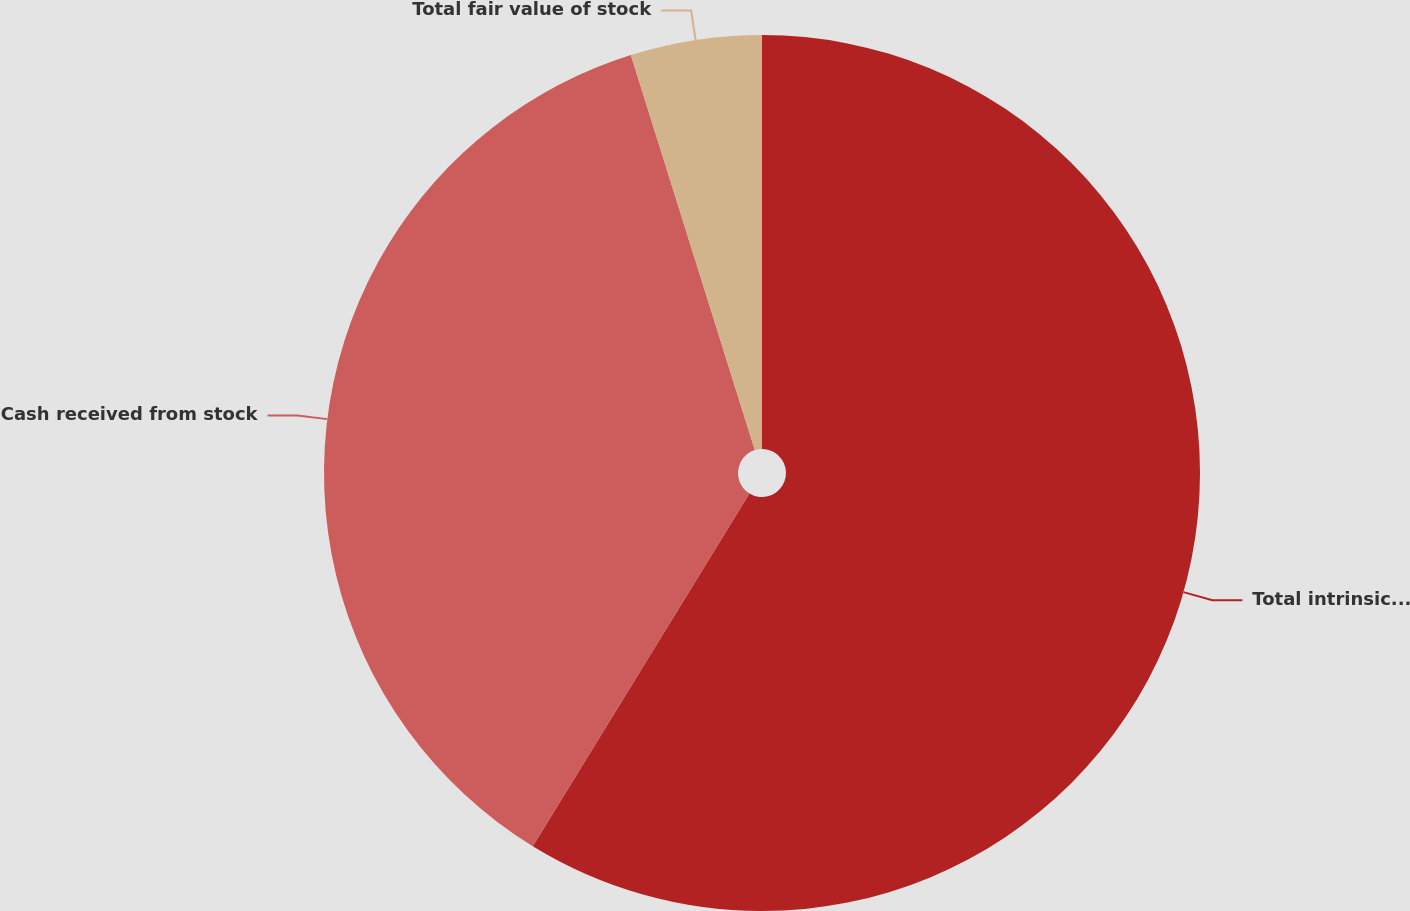Convert chart to OTSL. <chart><loc_0><loc_0><loc_500><loc_500><pie_chart><fcel>Total intrinsic value of stock<fcel>Cash received from stock<fcel>Total fair value of stock<nl><fcel>58.76%<fcel>36.39%<fcel>4.84%<nl></chart> 